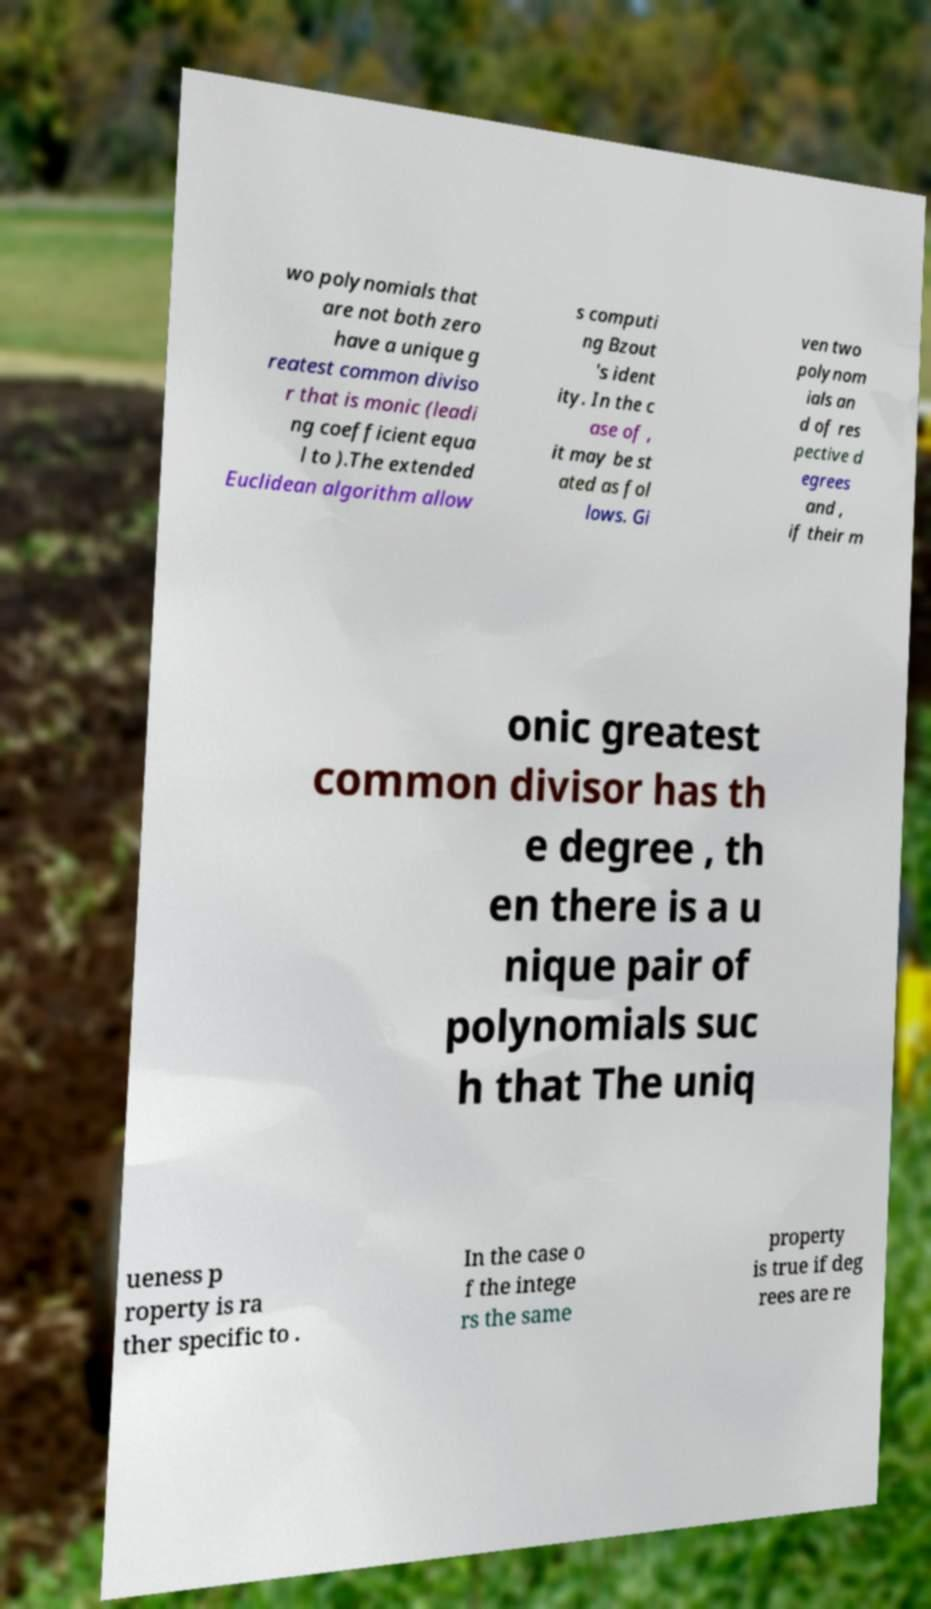Could you assist in decoding the text presented in this image and type it out clearly? wo polynomials that are not both zero have a unique g reatest common diviso r that is monic (leadi ng coefficient equa l to ).The extended Euclidean algorithm allow s computi ng Bzout 's ident ity. In the c ase of , it may be st ated as fol lows. Gi ven two polynom ials an d of res pective d egrees and , if their m onic greatest common divisor has th e degree , th en there is a u nique pair of polynomials suc h that The uniq ueness p roperty is ra ther specific to . In the case o f the intege rs the same property is true if deg rees are re 